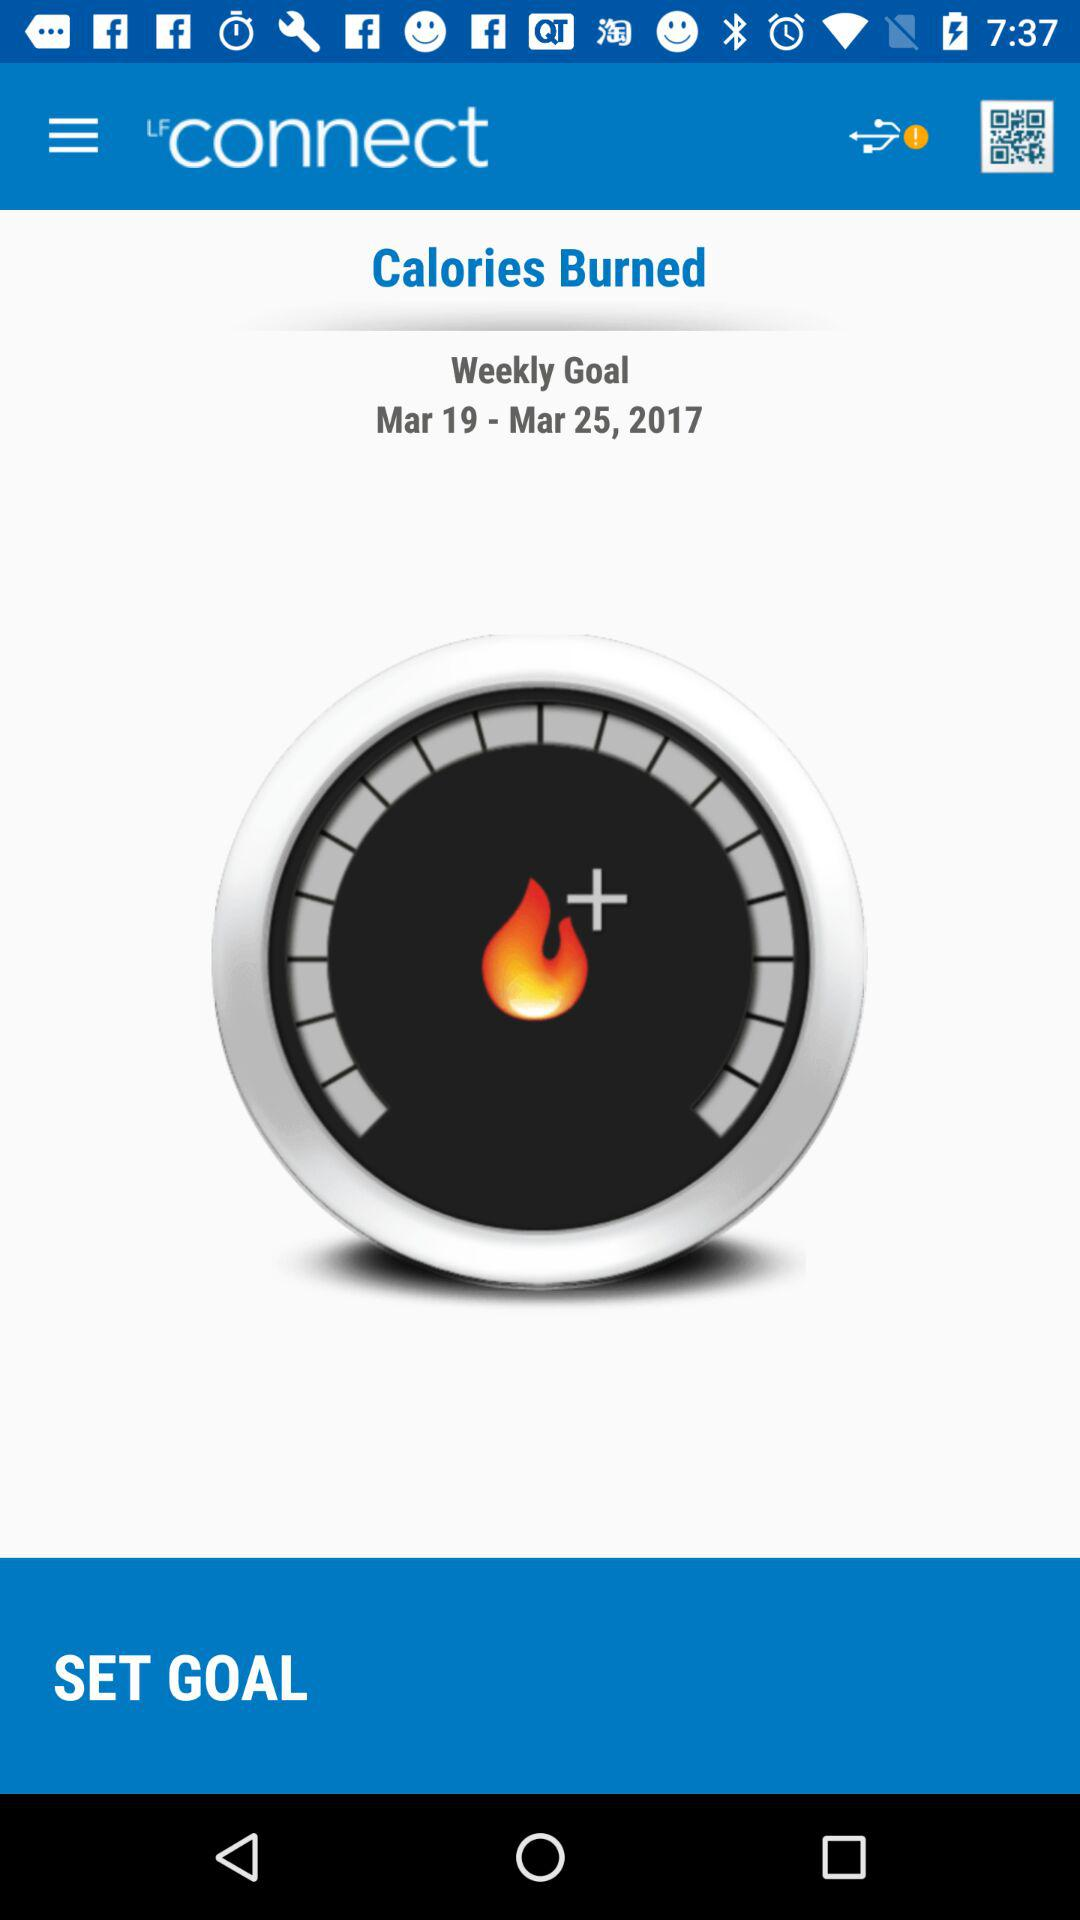What is the application name? The application name is "LFconnect". 